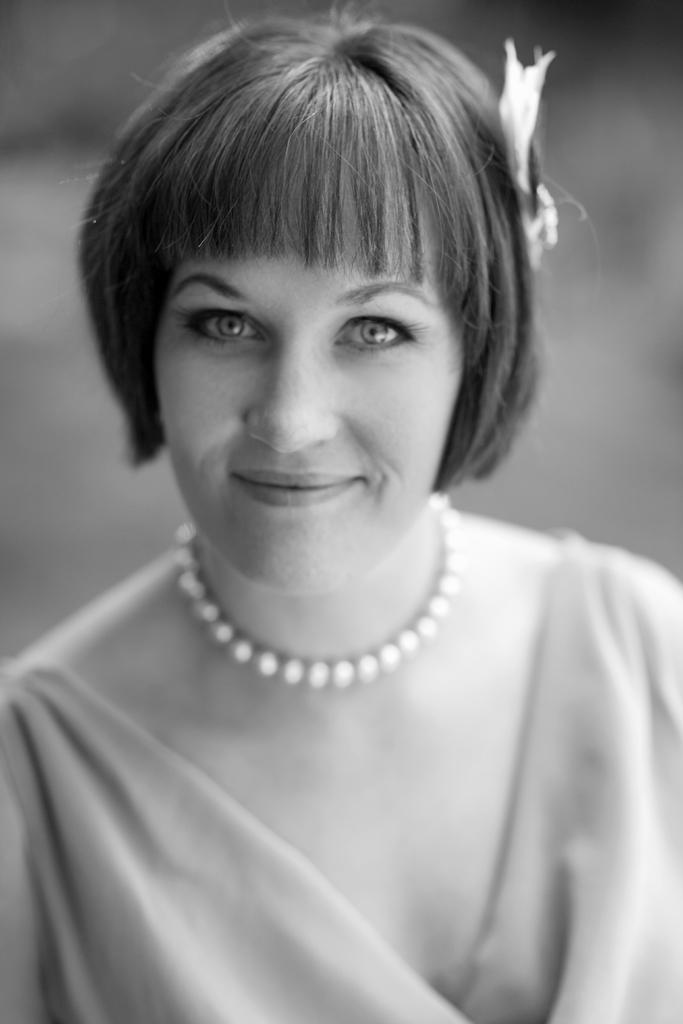What is the primary subject of the image? There is a woman in the image. What is the woman's facial expression in the image? The woman is smiling in the image. What type of scent can be detected in the image? There is no information about a scent in the image, so it cannot be determined. 